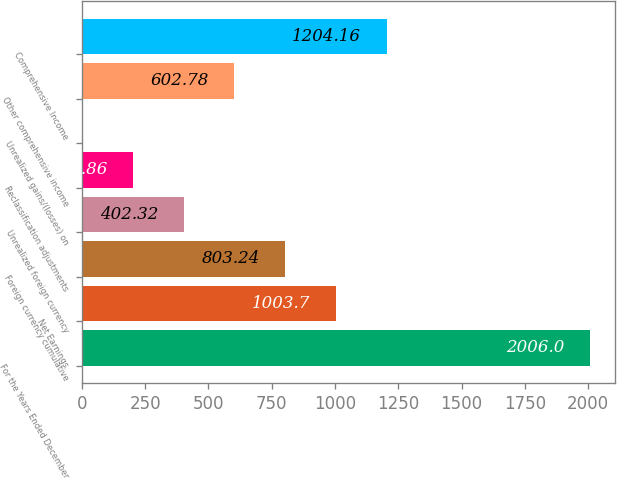Convert chart. <chart><loc_0><loc_0><loc_500><loc_500><bar_chart><fcel>For the Years Ended December<fcel>Net Earnings<fcel>Foreign currency cumulative<fcel>Unrealized foreign currency<fcel>Reclassification adjustments<fcel>Unrealized gains/(losses) on<fcel>Other comprehensive income<fcel>Comprehensive Income<nl><fcel>2006<fcel>1003.7<fcel>803.24<fcel>402.32<fcel>201.86<fcel>1.4<fcel>602.78<fcel>1204.16<nl></chart> 